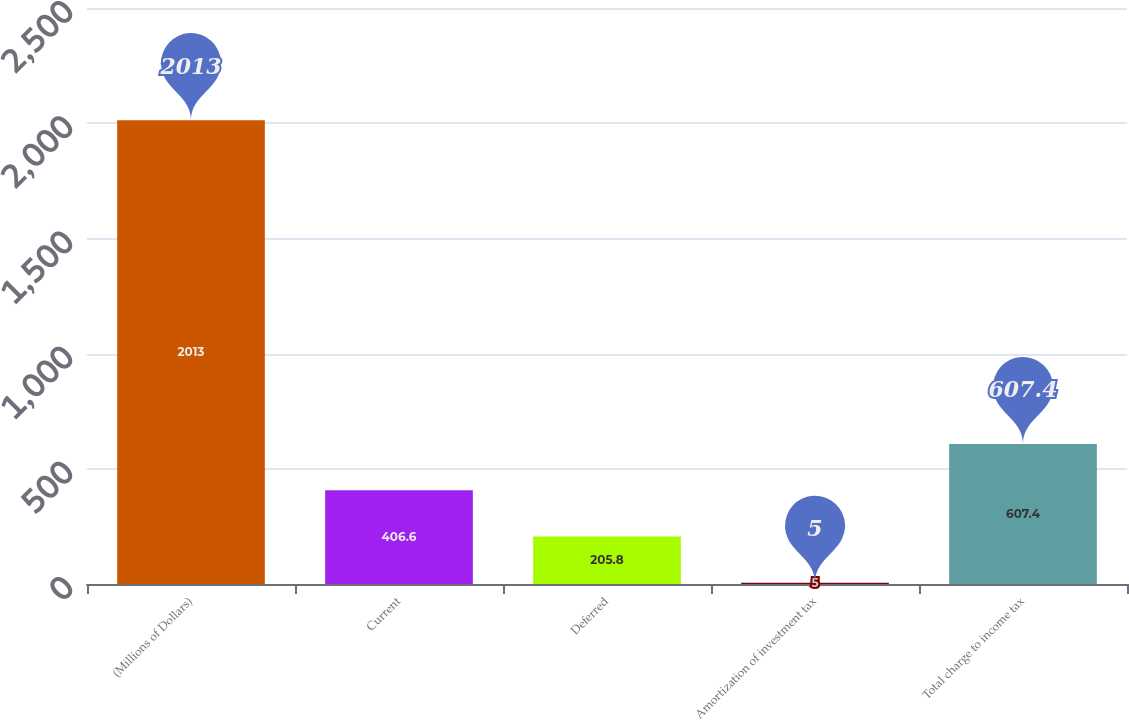<chart> <loc_0><loc_0><loc_500><loc_500><bar_chart><fcel>(Millions of Dollars)<fcel>Current<fcel>Deferred<fcel>Amortization of investment tax<fcel>Total charge to income tax<nl><fcel>2013<fcel>406.6<fcel>205.8<fcel>5<fcel>607.4<nl></chart> 